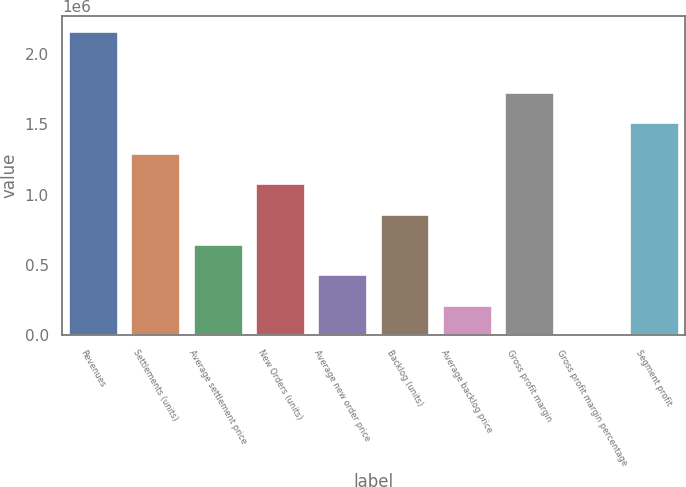Convert chart. <chart><loc_0><loc_0><loc_500><loc_500><bar_chart><fcel>Revenues<fcel>Settlements (units)<fcel>Average settlement price<fcel>New Orders (units)<fcel>Average new order price<fcel>Backlog (units)<fcel>Average backlog price<fcel>Gross profit margin<fcel>Gross profit margin percentage<fcel>Segment profit<nl><fcel>2.16176e+06<fcel>1.29706e+06<fcel>648539<fcel>1.08089e+06<fcel>432364<fcel>864714<fcel>216189<fcel>1.72941e+06<fcel>13.63<fcel>1.51324e+06<nl></chart> 